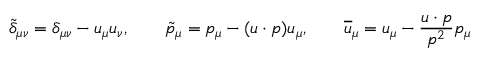<formula> <loc_0><loc_0><loc_500><loc_500>\tilde { \delta } _ { \mu \nu } = \delta _ { \mu \nu } - u _ { \mu } u _ { \nu } , \quad \tilde { p } _ { \mu } = p _ { \mu } - ( u \cdot p ) u _ { \mu } , \quad \overline { u } _ { \mu } = u _ { \mu } - \frac { u \cdot p } { p ^ { 2 } } p _ { \mu }</formula> 